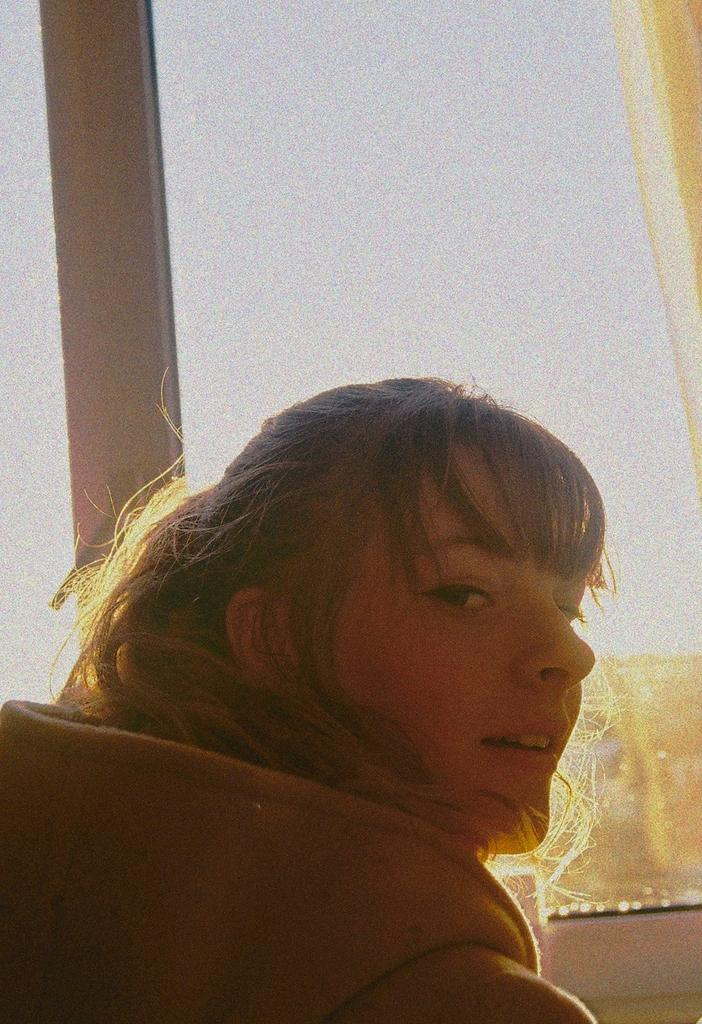Who is present in the image? There is a woman in the image. What is the woman wearing? The woman is wearing a jacket. What is the woman's facial expression? The woman is smiling. What type of window treatment is present in the image? There is a curtain in the image. What is the glass used for in the image? The glass is used to see objects through it. What can be seen in the sky in the image? The sky is visible in the image. Where is the faucet located in the image? There is no faucet present in the image. What type of shop can be seen in the background of the image? There is no shop visible in the image; it only features a woman, a curtain, a glass, and the sky. 